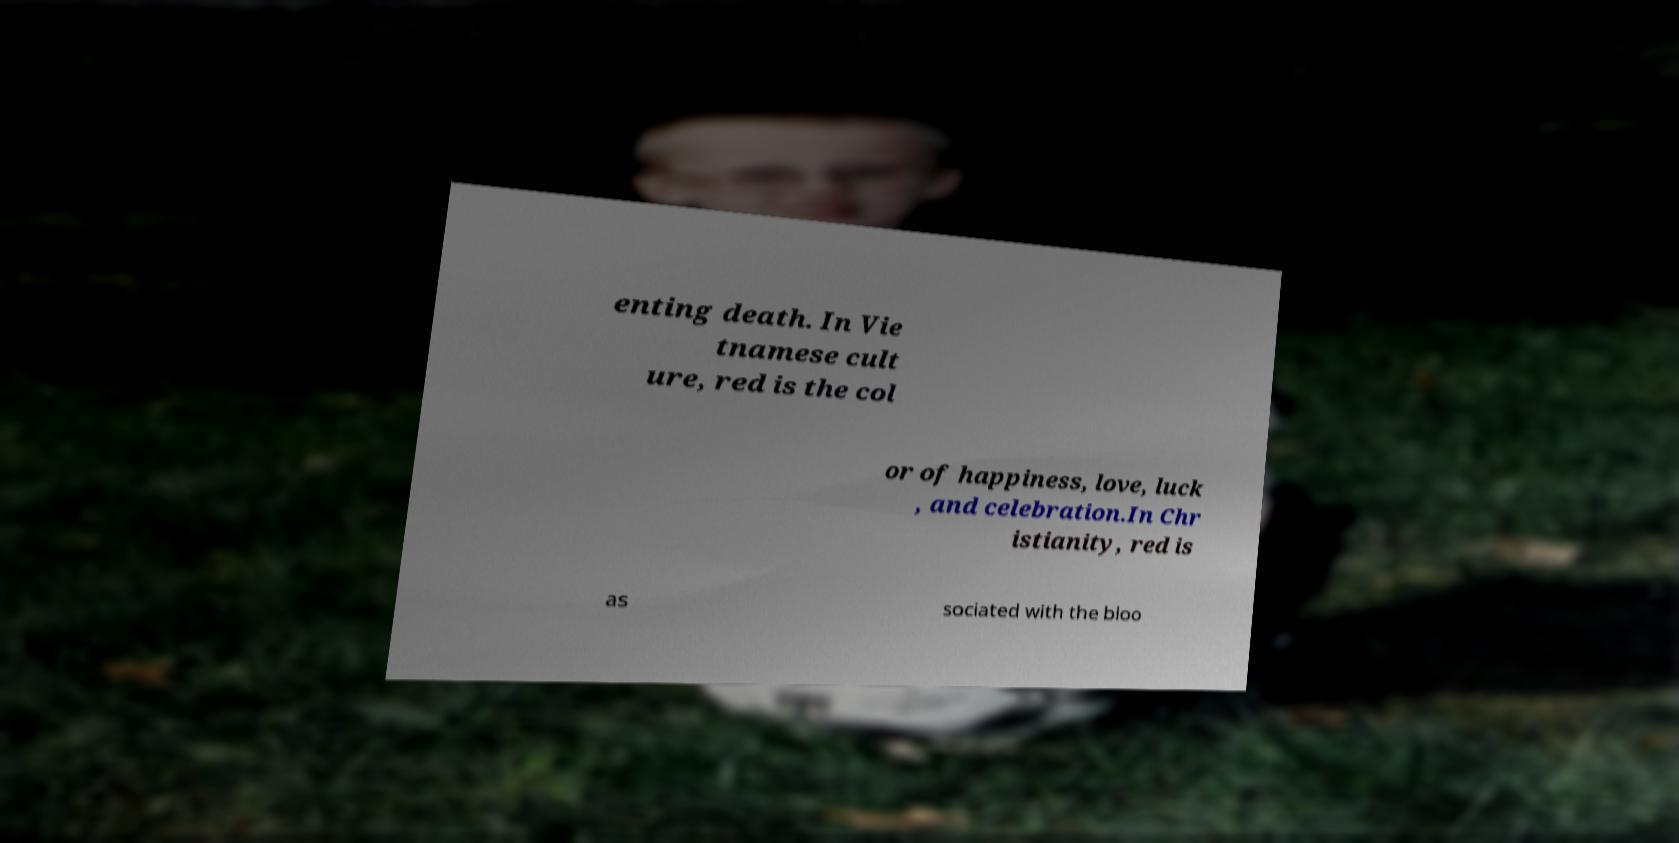Could you assist in decoding the text presented in this image and type it out clearly? enting death. In Vie tnamese cult ure, red is the col or of happiness, love, luck , and celebration.In Chr istianity, red is as sociated with the bloo 